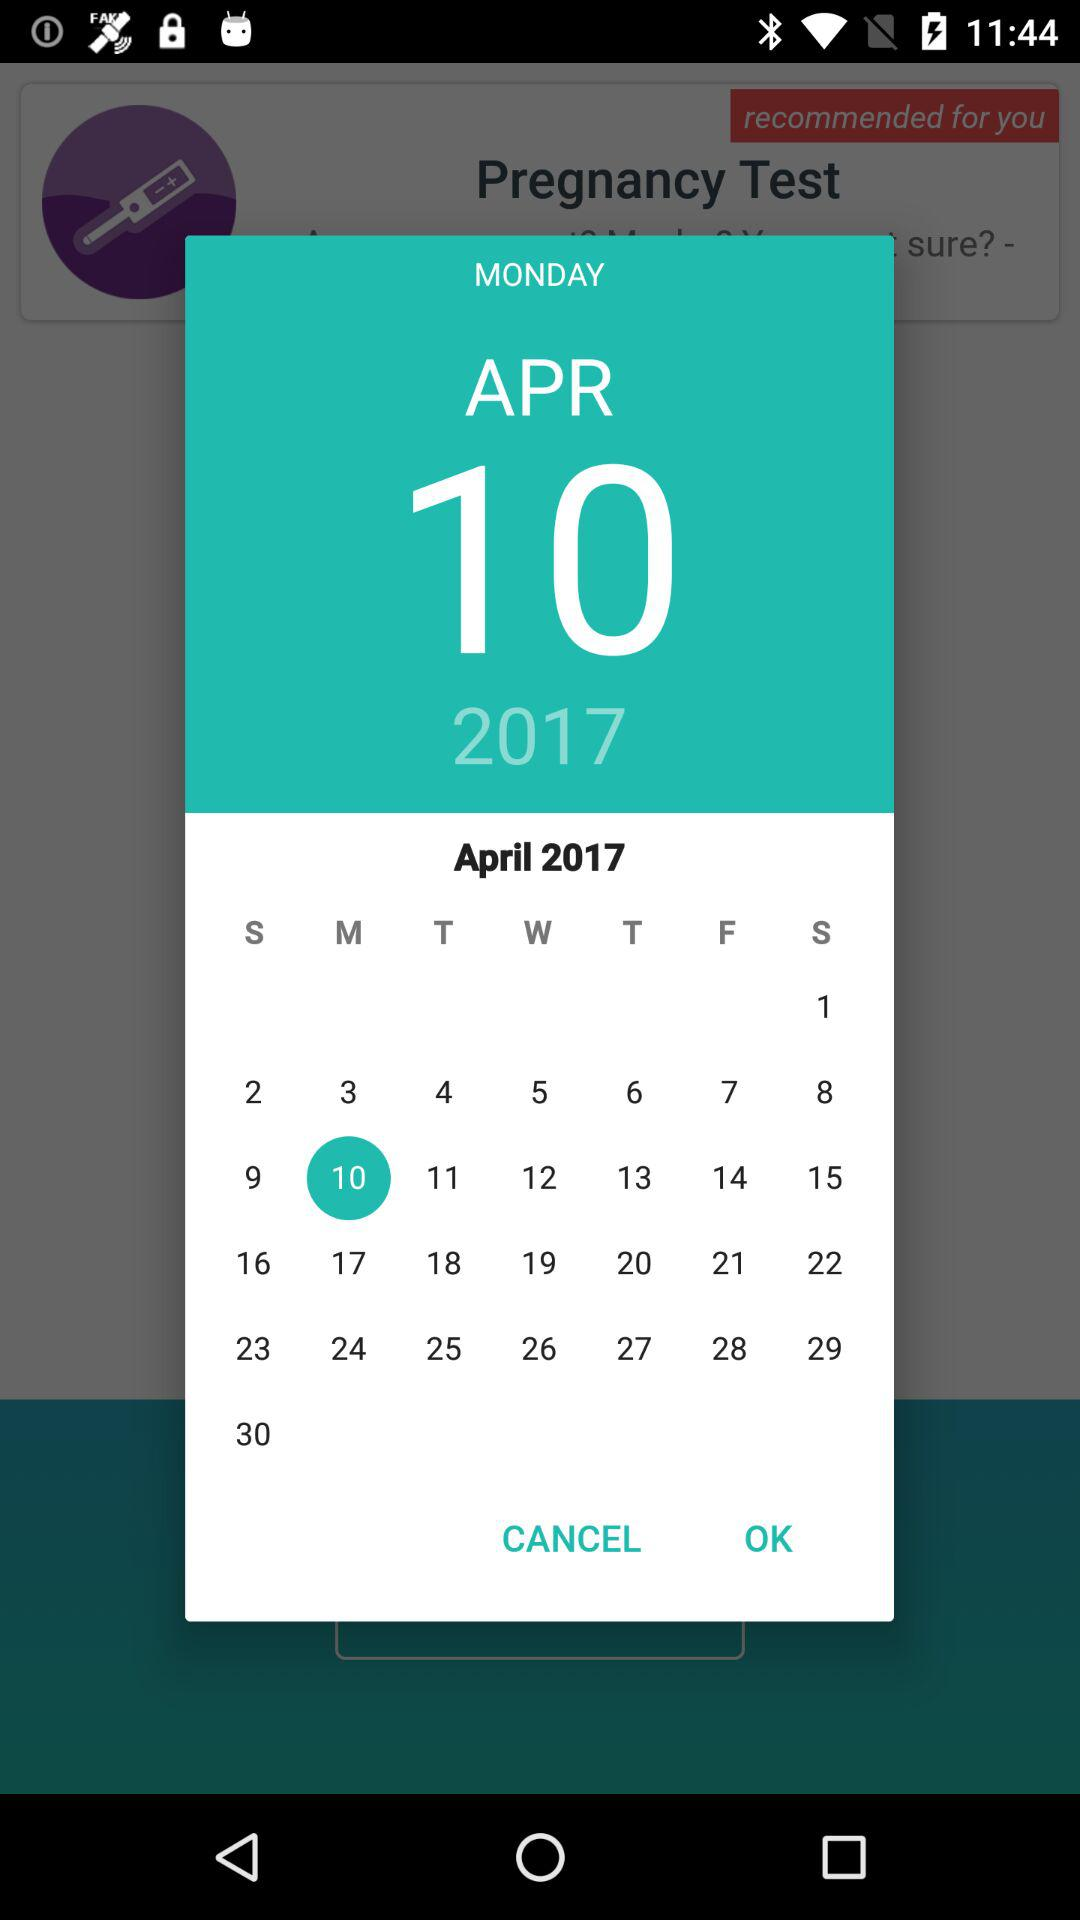What day is April 10, 2017? April 10, 2017 is Monday. 